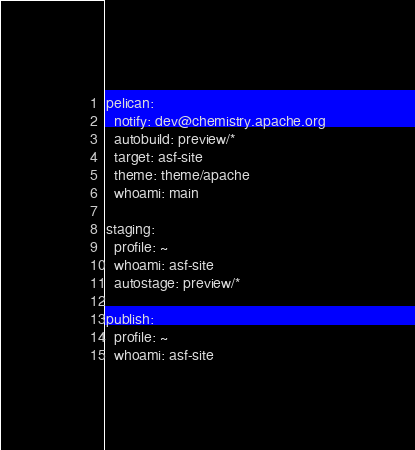<code> <loc_0><loc_0><loc_500><loc_500><_YAML_>pelican:
  notify: dev@chemistry.apache.org
  autobuild: preview/*
  target: asf-site
  theme: theme/apache
  whoami: main

staging:
  profile: ~
  whoami: asf-site
  autostage: preview/*

publish:
  profile: ~
  whoami: asf-site
</code> 